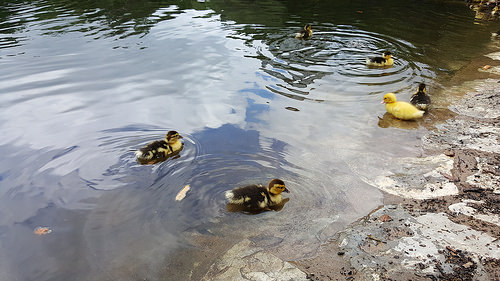<image>
Is there a duck on the water? Yes. Looking at the image, I can see the duck is positioned on top of the water, with the water providing support. Is the duck on the duck? No. The duck is not positioned on the duck. They may be near each other, but the duck is not supported by or resting on top of the duck. 